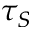<formula> <loc_0><loc_0><loc_500><loc_500>\tau _ { S }</formula> 